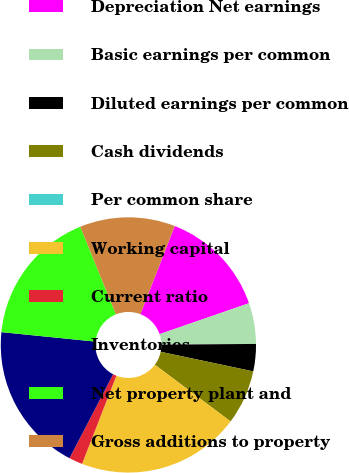Convert chart to OTSL. <chart><loc_0><loc_0><loc_500><loc_500><pie_chart><fcel>Depreciation Net earnings<fcel>Basic earnings per common<fcel>Diluted earnings per common<fcel>Cash dividends<fcel>Per common share<fcel>Working capital<fcel>Current ratio<fcel>Inventories<fcel>Net property plant and<fcel>Gross additions to property<nl><fcel>13.79%<fcel>5.17%<fcel>3.45%<fcel>6.9%<fcel>0.0%<fcel>20.69%<fcel>1.72%<fcel>18.97%<fcel>17.24%<fcel>12.07%<nl></chart> 